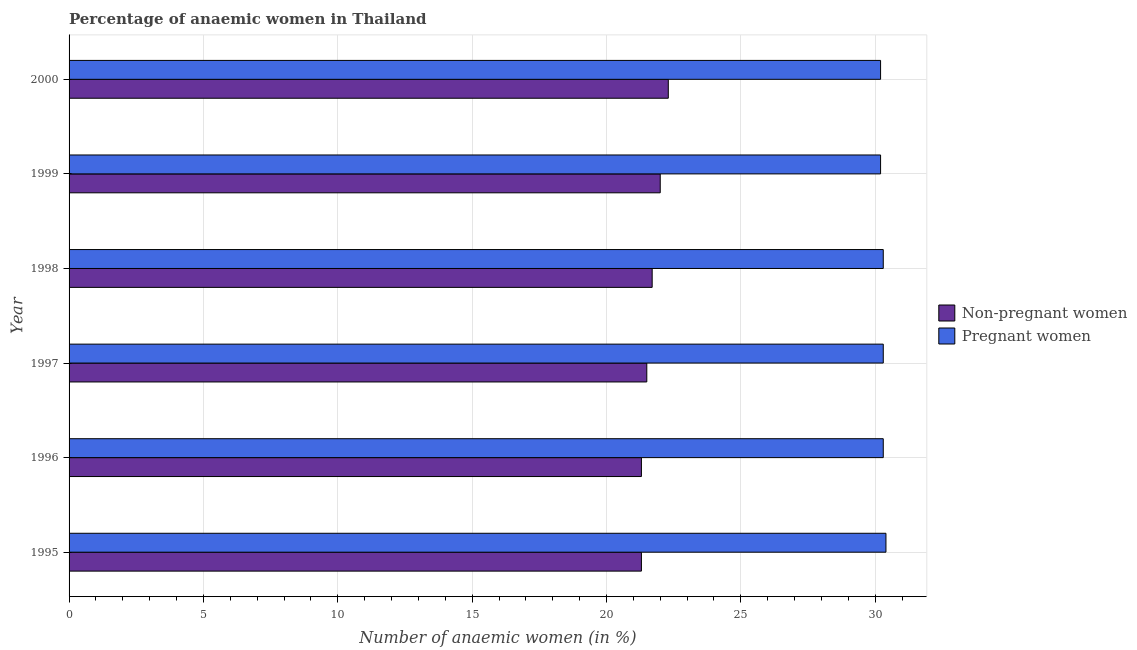How many different coloured bars are there?
Provide a succinct answer. 2. Are the number of bars on each tick of the Y-axis equal?
Offer a terse response. Yes. How many bars are there on the 3rd tick from the bottom?
Give a very brief answer. 2. What is the label of the 3rd group of bars from the top?
Make the answer very short. 1998. In how many cases, is the number of bars for a given year not equal to the number of legend labels?
Provide a short and direct response. 0. What is the percentage of pregnant anaemic women in 1995?
Keep it short and to the point. 30.4. Across all years, what is the maximum percentage of pregnant anaemic women?
Keep it short and to the point. 30.4. Across all years, what is the minimum percentage of non-pregnant anaemic women?
Your response must be concise. 21.3. In which year was the percentage of pregnant anaemic women maximum?
Give a very brief answer. 1995. What is the total percentage of pregnant anaemic women in the graph?
Offer a terse response. 181.7. What is the difference between the percentage of pregnant anaemic women in 2000 and the percentage of non-pregnant anaemic women in 1996?
Offer a very short reply. 8.9. What is the average percentage of pregnant anaemic women per year?
Keep it short and to the point. 30.28. In the year 1997, what is the difference between the percentage of non-pregnant anaemic women and percentage of pregnant anaemic women?
Keep it short and to the point. -8.8. What is the ratio of the percentage of pregnant anaemic women in 1997 to that in 1998?
Your answer should be very brief. 1. Is the percentage of non-pregnant anaemic women in 1997 less than that in 2000?
Keep it short and to the point. Yes. Is the difference between the percentage of pregnant anaemic women in 1997 and 1999 greater than the difference between the percentage of non-pregnant anaemic women in 1997 and 1999?
Offer a terse response. Yes. What is the difference between the highest and the second highest percentage of pregnant anaemic women?
Provide a succinct answer. 0.1. Is the sum of the percentage of non-pregnant anaemic women in 1995 and 2000 greater than the maximum percentage of pregnant anaemic women across all years?
Offer a terse response. Yes. What does the 1st bar from the top in 1998 represents?
Provide a short and direct response. Pregnant women. What does the 1st bar from the bottom in 2000 represents?
Make the answer very short. Non-pregnant women. How many bars are there?
Your answer should be compact. 12. How many years are there in the graph?
Provide a succinct answer. 6. Are the values on the major ticks of X-axis written in scientific E-notation?
Your response must be concise. No. Does the graph contain any zero values?
Offer a very short reply. No. How many legend labels are there?
Offer a terse response. 2. How are the legend labels stacked?
Your response must be concise. Vertical. What is the title of the graph?
Offer a terse response. Percentage of anaemic women in Thailand. Does "Foreign Liabilities" appear as one of the legend labels in the graph?
Your response must be concise. No. What is the label or title of the X-axis?
Offer a terse response. Number of anaemic women (in %). What is the Number of anaemic women (in %) of Non-pregnant women in 1995?
Give a very brief answer. 21.3. What is the Number of anaemic women (in %) of Pregnant women in 1995?
Your answer should be compact. 30.4. What is the Number of anaemic women (in %) of Non-pregnant women in 1996?
Your answer should be very brief. 21.3. What is the Number of anaemic women (in %) of Pregnant women in 1996?
Give a very brief answer. 30.3. What is the Number of anaemic women (in %) of Non-pregnant women in 1997?
Give a very brief answer. 21.5. What is the Number of anaemic women (in %) of Pregnant women in 1997?
Keep it short and to the point. 30.3. What is the Number of anaemic women (in %) in Non-pregnant women in 1998?
Give a very brief answer. 21.7. What is the Number of anaemic women (in %) of Pregnant women in 1998?
Ensure brevity in your answer.  30.3. What is the Number of anaemic women (in %) in Non-pregnant women in 1999?
Make the answer very short. 22. What is the Number of anaemic women (in %) in Pregnant women in 1999?
Give a very brief answer. 30.2. What is the Number of anaemic women (in %) of Non-pregnant women in 2000?
Offer a terse response. 22.3. What is the Number of anaemic women (in %) in Pregnant women in 2000?
Keep it short and to the point. 30.2. Across all years, what is the maximum Number of anaemic women (in %) of Non-pregnant women?
Make the answer very short. 22.3. Across all years, what is the maximum Number of anaemic women (in %) of Pregnant women?
Give a very brief answer. 30.4. Across all years, what is the minimum Number of anaemic women (in %) of Non-pregnant women?
Provide a succinct answer. 21.3. Across all years, what is the minimum Number of anaemic women (in %) of Pregnant women?
Your answer should be compact. 30.2. What is the total Number of anaemic women (in %) in Non-pregnant women in the graph?
Your response must be concise. 130.1. What is the total Number of anaemic women (in %) of Pregnant women in the graph?
Offer a terse response. 181.7. What is the difference between the Number of anaemic women (in %) of Non-pregnant women in 1995 and that in 1997?
Provide a succinct answer. -0.2. What is the difference between the Number of anaemic women (in %) in Pregnant women in 1995 and that in 1997?
Your answer should be very brief. 0.1. What is the difference between the Number of anaemic women (in %) in Non-pregnant women in 1995 and that in 1998?
Offer a terse response. -0.4. What is the difference between the Number of anaemic women (in %) of Pregnant women in 1995 and that in 1999?
Keep it short and to the point. 0.2. What is the difference between the Number of anaemic women (in %) of Pregnant women in 1995 and that in 2000?
Ensure brevity in your answer.  0.2. What is the difference between the Number of anaemic women (in %) in Non-pregnant women in 1996 and that in 1997?
Your answer should be compact. -0.2. What is the difference between the Number of anaemic women (in %) in Pregnant women in 1996 and that in 1997?
Provide a short and direct response. 0. What is the difference between the Number of anaemic women (in %) in Non-pregnant women in 1996 and that in 1998?
Offer a terse response. -0.4. What is the difference between the Number of anaemic women (in %) in Pregnant women in 1996 and that in 1998?
Your response must be concise. 0. What is the difference between the Number of anaemic women (in %) in Non-pregnant women in 1996 and that in 1999?
Your answer should be very brief. -0.7. What is the difference between the Number of anaemic women (in %) of Pregnant women in 1996 and that in 1999?
Provide a succinct answer. 0.1. What is the difference between the Number of anaemic women (in %) of Pregnant women in 1996 and that in 2000?
Make the answer very short. 0.1. What is the difference between the Number of anaemic women (in %) of Non-pregnant women in 1997 and that in 1998?
Provide a short and direct response. -0.2. What is the difference between the Number of anaemic women (in %) in Pregnant women in 1997 and that in 1998?
Ensure brevity in your answer.  0. What is the difference between the Number of anaemic women (in %) in Pregnant women in 1997 and that in 1999?
Your response must be concise. 0.1. What is the difference between the Number of anaemic women (in %) of Non-pregnant women in 1997 and that in 2000?
Ensure brevity in your answer.  -0.8. What is the difference between the Number of anaemic women (in %) in Non-pregnant women in 1998 and that in 2000?
Offer a terse response. -0.6. What is the difference between the Number of anaemic women (in %) of Pregnant women in 1998 and that in 2000?
Your answer should be very brief. 0.1. What is the difference between the Number of anaemic women (in %) of Pregnant women in 1999 and that in 2000?
Your response must be concise. 0. What is the difference between the Number of anaemic women (in %) of Non-pregnant women in 1995 and the Number of anaemic women (in %) of Pregnant women in 1996?
Your answer should be very brief. -9. What is the difference between the Number of anaemic women (in %) of Non-pregnant women in 1995 and the Number of anaemic women (in %) of Pregnant women in 1997?
Provide a short and direct response. -9. What is the difference between the Number of anaemic women (in %) of Non-pregnant women in 1995 and the Number of anaemic women (in %) of Pregnant women in 1999?
Your answer should be very brief. -8.9. What is the difference between the Number of anaemic women (in %) in Non-pregnant women in 1996 and the Number of anaemic women (in %) in Pregnant women in 1997?
Your answer should be very brief. -9. What is the difference between the Number of anaemic women (in %) in Non-pregnant women in 1996 and the Number of anaemic women (in %) in Pregnant women in 1998?
Keep it short and to the point. -9. What is the difference between the Number of anaemic women (in %) in Non-pregnant women in 1997 and the Number of anaemic women (in %) in Pregnant women in 1998?
Offer a terse response. -8.8. What is the difference between the Number of anaemic women (in %) in Non-pregnant women in 1997 and the Number of anaemic women (in %) in Pregnant women in 1999?
Make the answer very short. -8.7. What is the difference between the Number of anaemic women (in %) of Non-pregnant women in 1997 and the Number of anaemic women (in %) of Pregnant women in 2000?
Your response must be concise. -8.7. What is the average Number of anaemic women (in %) of Non-pregnant women per year?
Offer a very short reply. 21.68. What is the average Number of anaemic women (in %) in Pregnant women per year?
Offer a terse response. 30.28. In the year 1995, what is the difference between the Number of anaemic women (in %) in Non-pregnant women and Number of anaemic women (in %) in Pregnant women?
Your answer should be compact. -9.1. In the year 1996, what is the difference between the Number of anaemic women (in %) in Non-pregnant women and Number of anaemic women (in %) in Pregnant women?
Your response must be concise. -9. In the year 1997, what is the difference between the Number of anaemic women (in %) of Non-pregnant women and Number of anaemic women (in %) of Pregnant women?
Keep it short and to the point. -8.8. What is the ratio of the Number of anaemic women (in %) of Non-pregnant women in 1995 to that in 1996?
Offer a very short reply. 1. What is the ratio of the Number of anaemic women (in %) in Non-pregnant women in 1995 to that in 1998?
Your response must be concise. 0.98. What is the ratio of the Number of anaemic women (in %) of Pregnant women in 1995 to that in 1998?
Give a very brief answer. 1. What is the ratio of the Number of anaemic women (in %) of Non-pregnant women in 1995 to that in 1999?
Ensure brevity in your answer.  0.97. What is the ratio of the Number of anaemic women (in %) of Pregnant women in 1995 to that in 1999?
Offer a terse response. 1.01. What is the ratio of the Number of anaemic women (in %) of Non-pregnant women in 1995 to that in 2000?
Make the answer very short. 0.96. What is the ratio of the Number of anaemic women (in %) of Pregnant women in 1995 to that in 2000?
Give a very brief answer. 1.01. What is the ratio of the Number of anaemic women (in %) of Non-pregnant women in 1996 to that in 1997?
Provide a short and direct response. 0.99. What is the ratio of the Number of anaemic women (in %) in Pregnant women in 1996 to that in 1997?
Your answer should be very brief. 1. What is the ratio of the Number of anaemic women (in %) in Non-pregnant women in 1996 to that in 1998?
Keep it short and to the point. 0.98. What is the ratio of the Number of anaemic women (in %) of Pregnant women in 1996 to that in 1998?
Your response must be concise. 1. What is the ratio of the Number of anaemic women (in %) of Non-pregnant women in 1996 to that in 1999?
Give a very brief answer. 0.97. What is the ratio of the Number of anaemic women (in %) in Pregnant women in 1996 to that in 1999?
Make the answer very short. 1. What is the ratio of the Number of anaemic women (in %) of Non-pregnant women in 1996 to that in 2000?
Keep it short and to the point. 0.96. What is the ratio of the Number of anaemic women (in %) of Non-pregnant women in 1997 to that in 1998?
Your answer should be compact. 0.99. What is the ratio of the Number of anaemic women (in %) of Pregnant women in 1997 to that in 1998?
Your answer should be compact. 1. What is the ratio of the Number of anaemic women (in %) in Non-pregnant women in 1997 to that in 1999?
Offer a terse response. 0.98. What is the ratio of the Number of anaemic women (in %) of Non-pregnant women in 1997 to that in 2000?
Your answer should be very brief. 0.96. What is the ratio of the Number of anaemic women (in %) in Non-pregnant women in 1998 to that in 1999?
Your answer should be compact. 0.99. What is the ratio of the Number of anaemic women (in %) in Pregnant women in 1998 to that in 1999?
Ensure brevity in your answer.  1. What is the ratio of the Number of anaemic women (in %) in Non-pregnant women in 1998 to that in 2000?
Offer a terse response. 0.97. What is the ratio of the Number of anaemic women (in %) in Non-pregnant women in 1999 to that in 2000?
Ensure brevity in your answer.  0.99. What is the difference between the highest and the second highest Number of anaemic women (in %) in Pregnant women?
Offer a very short reply. 0.1. What is the difference between the highest and the lowest Number of anaemic women (in %) of Non-pregnant women?
Your answer should be compact. 1. 